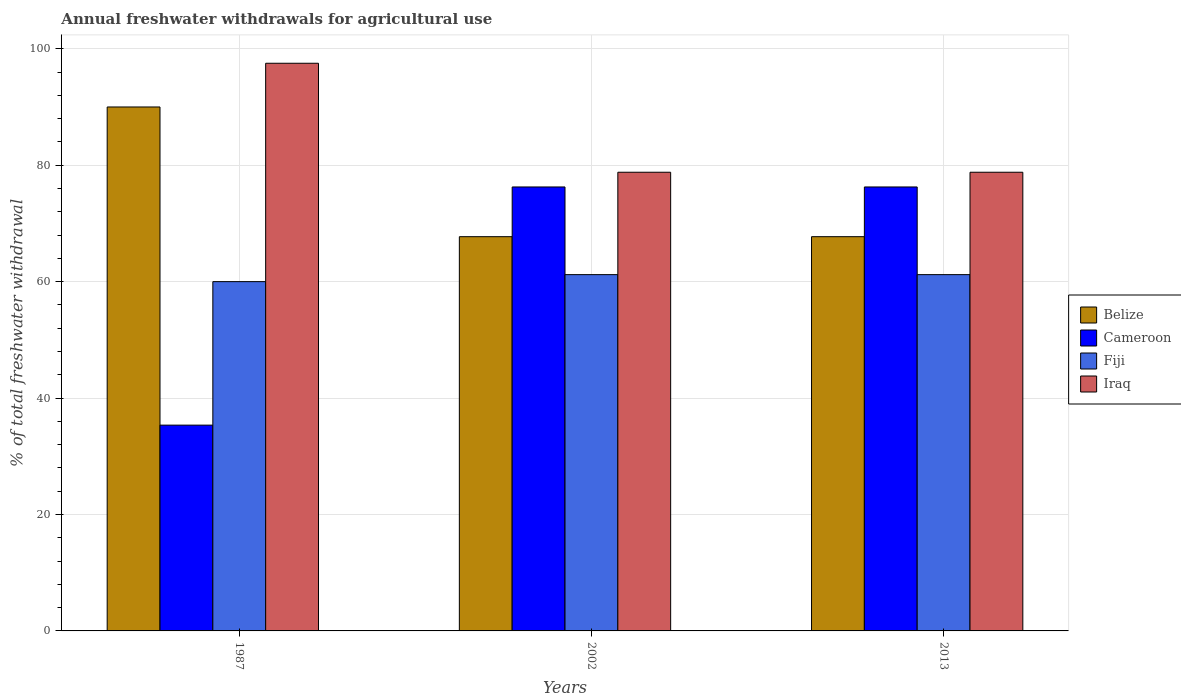How many different coloured bars are there?
Give a very brief answer. 4. How many groups of bars are there?
Keep it short and to the point. 3. Are the number of bars per tick equal to the number of legend labels?
Provide a succinct answer. Yes. Are the number of bars on each tick of the X-axis equal?
Offer a very short reply. Yes. How many bars are there on the 3rd tick from the left?
Your answer should be compact. 4. How many bars are there on the 3rd tick from the right?
Give a very brief answer. 4. Across all years, what is the minimum total annual withdrawals from freshwater in Cameroon?
Keep it short and to the point. 35.35. In which year was the total annual withdrawals from freshwater in Cameroon maximum?
Provide a succinct answer. 2002. What is the total total annual withdrawals from freshwater in Belize in the graph?
Provide a short and direct response. 225.44. What is the difference between the total annual withdrawals from freshwater in Iraq in 1987 and that in 2013?
Provide a succinct answer. 18.72. What is the difference between the total annual withdrawals from freshwater in Belize in 2002 and the total annual withdrawals from freshwater in Cameroon in 2013?
Your answer should be very brief. -8.54. What is the average total annual withdrawals from freshwater in Fiji per year?
Give a very brief answer. 60.8. In the year 1987, what is the difference between the total annual withdrawals from freshwater in Fiji and total annual withdrawals from freshwater in Iraq?
Provide a short and direct response. -37.51. In how many years, is the total annual withdrawals from freshwater in Belize greater than 88 %?
Offer a very short reply. 1. What is the ratio of the total annual withdrawals from freshwater in Belize in 1987 to that in 2002?
Provide a short and direct response. 1.33. Is the total annual withdrawals from freshwater in Fiji in 1987 less than that in 2002?
Your answer should be very brief. Yes. Is the difference between the total annual withdrawals from freshwater in Fiji in 1987 and 2002 greater than the difference between the total annual withdrawals from freshwater in Iraq in 1987 and 2002?
Make the answer very short. No. What is the difference between the highest and the second highest total annual withdrawals from freshwater in Fiji?
Offer a terse response. 0. What is the difference between the highest and the lowest total annual withdrawals from freshwater in Iraq?
Your answer should be compact. 18.72. What does the 1st bar from the left in 2002 represents?
Your answer should be compact. Belize. What does the 3rd bar from the right in 2002 represents?
Your answer should be compact. Cameroon. Is it the case that in every year, the sum of the total annual withdrawals from freshwater in Iraq and total annual withdrawals from freshwater in Fiji is greater than the total annual withdrawals from freshwater in Belize?
Keep it short and to the point. Yes. How many bars are there?
Your response must be concise. 12. Are all the bars in the graph horizontal?
Your answer should be compact. No. What is the difference between two consecutive major ticks on the Y-axis?
Offer a very short reply. 20. Does the graph contain any zero values?
Your answer should be compact. No. Does the graph contain grids?
Give a very brief answer. Yes. What is the title of the graph?
Your response must be concise. Annual freshwater withdrawals for agricultural use. What is the label or title of the X-axis?
Provide a succinct answer. Years. What is the label or title of the Y-axis?
Your response must be concise. % of total freshwater withdrawal. What is the % of total freshwater withdrawal of Cameroon in 1987?
Ensure brevity in your answer.  35.35. What is the % of total freshwater withdrawal of Fiji in 1987?
Provide a succinct answer. 60. What is the % of total freshwater withdrawal in Iraq in 1987?
Provide a short and direct response. 97.51. What is the % of total freshwater withdrawal in Belize in 2002?
Keep it short and to the point. 67.72. What is the % of total freshwater withdrawal of Cameroon in 2002?
Provide a short and direct response. 76.26. What is the % of total freshwater withdrawal in Fiji in 2002?
Give a very brief answer. 61.2. What is the % of total freshwater withdrawal of Iraq in 2002?
Offer a terse response. 78.79. What is the % of total freshwater withdrawal in Belize in 2013?
Your answer should be very brief. 67.72. What is the % of total freshwater withdrawal in Cameroon in 2013?
Your response must be concise. 76.26. What is the % of total freshwater withdrawal in Fiji in 2013?
Your answer should be very brief. 61.2. What is the % of total freshwater withdrawal in Iraq in 2013?
Your response must be concise. 78.79. Across all years, what is the maximum % of total freshwater withdrawal in Belize?
Provide a short and direct response. 90. Across all years, what is the maximum % of total freshwater withdrawal of Cameroon?
Offer a terse response. 76.26. Across all years, what is the maximum % of total freshwater withdrawal in Fiji?
Offer a terse response. 61.2. Across all years, what is the maximum % of total freshwater withdrawal of Iraq?
Provide a short and direct response. 97.51. Across all years, what is the minimum % of total freshwater withdrawal of Belize?
Offer a very short reply. 67.72. Across all years, what is the minimum % of total freshwater withdrawal of Cameroon?
Keep it short and to the point. 35.35. Across all years, what is the minimum % of total freshwater withdrawal of Iraq?
Ensure brevity in your answer.  78.79. What is the total % of total freshwater withdrawal of Belize in the graph?
Offer a very short reply. 225.44. What is the total % of total freshwater withdrawal in Cameroon in the graph?
Your response must be concise. 187.87. What is the total % of total freshwater withdrawal in Fiji in the graph?
Make the answer very short. 182.4. What is the total % of total freshwater withdrawal in Iraq in the graph?
Offer a terse response. 255.09. What is the difference between the % of total freshwater withdrawal in Belize in 1987 and that in 2002?
Give a very brief answer. 22.28. What is the difference between the % of total freshwater withdrawal of Cameroon in 1987 and that in 2002?
Your answer should be very brief. -40.91. What is the difference between the % of total freshwater withdrawal of Iraq in 1987 and that in 2002?
Your answer should be compact. 18.72. What is the difference between the % of total freshwater withdrawal of Belize in 1987 and that in 2013?
Provide a short and direct response. 22.28. What is the difference between the % of total freshwater withdrawal in Cameroon in 1987 and that in 2013?
Make the answer very short. -40.91. What is the difference between the % of total freshwater withdrawal in Iraq in 1987 and that in 2013?
Your answer should be very brief. 18.72. What is the difference between the % of total freshwater withdrawal of Cameroon in 2002 and that in 2013?
Keep it short and to the point. 0. What is the difference between the % of total freshwater withdrawal in Iraq in 2002 and that in 2013?
Provide a short and direct response. 0. What is the difference between the % of total freshwater withdrawal in Belize in 1987 and the % of total freshwater withdrawal in Cameroon in 2002?
Provide a succinct answer. 13.74. What is the difference between the % of total freshwater withdrawal in Belize in 1987 and the % of total freshwater withdrawal in Fiji in 2002?
Your response must be concise. 28.8. What is the difference between the % of total freshwater withdrawal of Belize in 1987 and the % of total freshwater withdrawal of Iraq in 2002?
Keep it short and to the point. 11.21. What is the difference between the % of total freshwater withdrawal in Cameroon in 1987 and the % of total freshwater withdrawal in Fiji in 2002?
Your response must be concise. -25.85. What is the difference between the % of total freshwater withdrawal in Cameroon in 1987 and the % of total freshwater withdrawal in Iraq in 2002?
Ensure brevity in your answer.  -43.44. What is the difference between the % of total freshwater withdrawal in Fiji in 1987 and the % of total freshwater withdrawal in Iraq in 2002?
Your answer should be compact. -18.79. What is the difference between the % of total freshwater withdrawal of Belize in 1987 and the % of total freshwater withdrawal of Cameroon in 2013?
Provide a short and direct response. 13.74. What is the difference between the % of total freshwater withdrawal of Belize in 1987 and the % of total freshwater withdrawal of Fiji in 2013?
Offer a terse response. 28.8. What is the difference between the % of total freshwater withdrawal in Belize in 1987 and the % of total freshwater withdrawal in Iraq in 2013?
Provide a succinct answer. 11.21. What is the difference between the % of total freshwater withdrawal in Cameroon in 1987 and the % of total freshwater withdrawal in Fiji in 2013?
Offer a terse response. -25.85. What is the difference between the % of total freshwater withdrawal of Cameroon in 1987 and the % of total freshwater withdrawal of Iraq in 2013?
Offer a terse response. -43.44. What is the difference between the % of total freshwater withdrawal in Fiji in 1987 and the % of total freshwater withdrawal in Iraq in 2013?
Ensure brevity in your answer.  -18.79. What is the difference between the % of total freshwater withdrawal in Belize in 2002 and the % of total freshwater withdrawal in Cameroon in 2013?
Give a very brief answer. -8.54. What is the difference between the % of total freshwater withdrawal in Belize in 2002 and the % of total freshwater withdrawal in Fiji in 2013?
Keep it short and to the point. 6.52. What is the difference between the % of total freshwater withdrawal of Belize in 2002 and the % of total freshwater withdrawal of Iraq in 2013?
Ensure brevity in your answer.  -11.07. What is the difference between the % of total freshwater withdrawal in Cameroon in 2002 and the % of total freshwater withdrawal in Fiji in 2013?
Offer a very short reply. 15.06. What is the difference between the % of total freshwater withdrawal of Cameroon in 2002 and the % of total freshwater withdrawal of Iraq in 2013?
Offer a terse response. -2.53. What is the difference between the % of total freshwater withdrawal of Fiji in 2002 and the % of total freshwater withdrawal of Iraq in 2013?
Provide a short and direct response. -17.59. What is the average % of total freshwater withdrawal in Belize per year?
Keep it short and to the point. 75.15. What is the average % of total freshwater withdrawal of Cameroon per year?
Keep it short and to the point. 62.62. What is the average % of total freshwater withdrawal in Fiji per year?
Offer a very short reply. 60.8. What is the average % of total freshwater withdrawal in Iraq per year?
Your answer should be very brief. 85.03. In the year 1987, what is the difference between the % of total freshwater withdrawal of Belize and % of total freshwater withdrawal of Cameroon?
Offer a terse response. 54.65. In the year 1987, what is the difference between the % of total freshwater withdrawal in Belize and % of total freshwater withdrawal in Iraq?
Provide a succinct answer. -7.51. In the year 1987, what is the difference between the % of total freshwater withdrawal in Cameroon and % of total freshwater withdrawal in Fiji?
Keep it short and to the point. -24.65. In the year 1987, what is the difference between the % of total freshwater withdrawal in Cameroon and % of total freshwater withdrawal in Iraq?
Offer a very short reply. -62.16. In the year 1987, what is the difference between the % of total freshwater withdrawal of Fiji and % of total freshwater withdrawal of Iraq?
Offer a terse response. -37.51. In the year 2002, what is the difference between the % of total freshwater withdrawal of Belize and % of total freshwater withdrawal of Cameroon?
Offer a very short reply. -8.54. In the year 2002, what is the difference between the % of total freshwater withdrawal of Belize and % of total freshwater withdrawal of Fiji?
Keep it short and to the point. 6.52. In the year 2002, what is the difference between the % of total freshwater withdrawal of Belize and % of total freshwater withdrawal of Iraq?
Ensure brevity in your answer.  -11.07. In the year 2002, what is the difference between the % of total freshwater withdrawal of Cameroon and % of total freshwater withdrawal of Fiji?
Provide a succinct answer. 15.06. In the year 2002, what is the difference between the % of total freshwater withdrawal of Cameroon and % of total freshwater withdrawal of Iraq?
Ensure brevity in your answer.  -2.53. In the year 2002, what is the difference between the % of total freshwater withdrawal in Fiji and % of total freshwater withdrawal in Iraq?
Offer a terse response. -17.59. In the year 2013, what is the difference between the % of total freshwater withdrawal of Belize and % of total freshwater withdrawal of Cameroon?
Keep it short and to the point. -8.54. In the year 2013, what is the difference between the % of total freshwater withdrawal in Belize and % of total freshwater withdrawal in Fiji?
Ensure brevity in your answer.  6.52. In the year 2013, what is the difference between the % of total freshwater withdrawal of Belize and % of total freshwater withdrawal of Iraq?
Keep it short and to the point. -11.07. In the year 2013, what is the difference between the % of total freshwater withdrawal of Cameroon and % of total freshwater withdrawal of Fiji?
Offer a terse response. 15.06. In the year 2013, what is the difference between the % of total freshwater withdrawal of Cameroon and % of total freshwater withdrawal of Iraq?
Make the answer very short. -2.53. In the year 2013, what is the difference between the % of total freshwater withdrawal in Fiji and % of total freshwater withdrawal in Iraq?
Keep it short and to the point. -17.59. What is the ratio of the % of total freshwater withdrawal of Belize in 1987 to that in 2002?
Ensure brevity in your answer.  1.33. What is the ratio of the % of total freshwater withdrawal of Cameroon in 1987 to that in 2002?
Keep it short and to the point. 0.46. What is the ratio of the % of total freshwater withdrawal in Fiji in 1987 to that in 2002?
Give a very brief answer. 0.98. What is the ratio of the % of total freshwater withdrawal in Iraq in 1987 to that in 2002?
Give a very brief answer. 1.24. What is the ratio of the % of total freshwater withdrawal of Belize in 1987 to that in 2013?
Keep it short and to the point. 1.33. What is the ratio of the % of total freshwater withdrawal of Cameroon in 1987 to that in 2013?
Offer a terse response. 0.46. What is the ratio of the % of total freshwater withdrawal in Fiji in 1987 to that in 2013?
Make the answer very short. 0.98. What is the ratio of the % of total freshwater withdrawal in Iraq in 1987 to that in 2013?
Offer a very short reply. 1.24. What is the ratio of the % of total freshwater withdrawal in Cameroon in 2002 to that in 2013?
Make the answer very short. 1. What is the ratio of the % of total freshwater withdrawal of Fiji in 2002 to that in 2013?
Provide a short and direct response. 1. What is the ratio of the % of total freshwater withdrawal in Iraq in 2002 to that in 2013?
Provide a succinct answer. 1. What is the difference between the highest and the second highest % of total freshwater withdrawal in Belize?
Offer a very short reply. 22.28. What is the difference between the highest and the second highest % of total freshwater withdrawal of Iraq?
Provide a short and direct response. 18.72. What is the difference between the highest and the lowest % of total freshwater withdrawal of Belize?
Offer a terse response. 22.28. What is the difference between the highest and the lowest % of total freshwater withdrawal of Cameroon?
Offer a terse response. 40.91. What is the difference between the highest and the lowest % of total freshwater withdrawal in Iraq?
Your answer should be very brief. 18.72. 